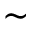Convert formula to latex. <formula><loc_0><loc_0><loc_500><loc_500>\sim</formula> 